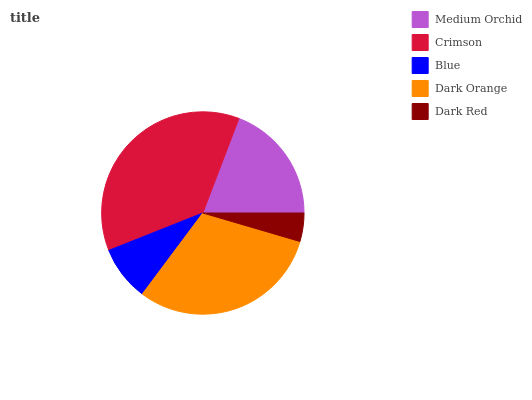Is Dark Red the minimum?
Answer yes or no. Yes. Is Crimson the maximum?
Answer yes or no. Yes. Is Blue the minimum?
Answer yes or no. No. Is Blue the maximum?
Answer yes or no. No. Is Crimson greater than Blue?
Answer yes or no. Yes. Is Blue less than Crimson?
Answer yes or no. Yes. Is Blue greater than Crimson?
Answer yes or no. No. Is Crimson less than Blue?
Answer yes or no. No. Is Medium Orchid the high median?
Answer yes or no. Yes. Is Medium Orchid the low median?
Answer yes or no. Yes. Is Blue the high median?
Answer yes or no. No. Is Crimson the low median?
Answer yes or no. No. 